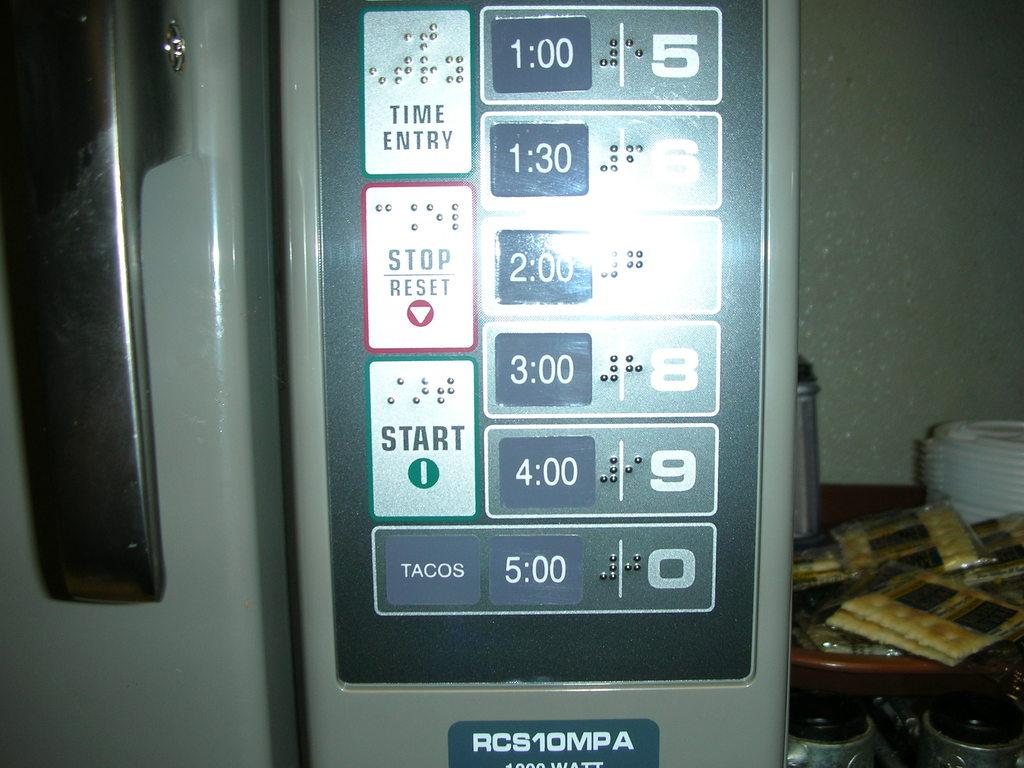<image>
Offer a succinct explanation of the picture presented. a digital display close up with buttons reading START and RESET 